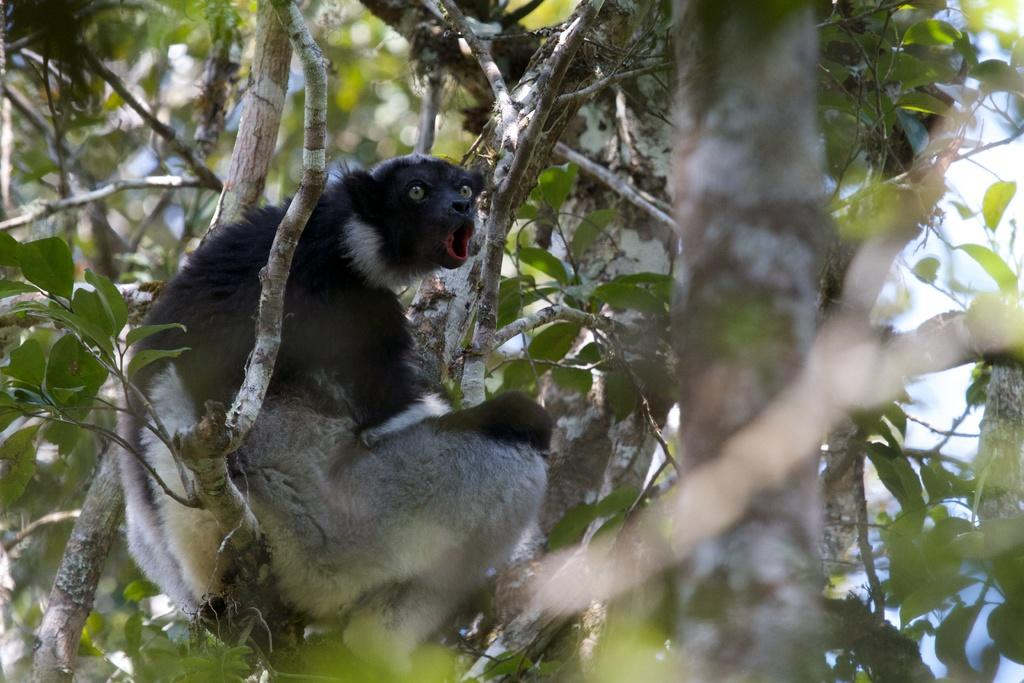What is on the tree branch in the image? There is an animal on a tree branch in the image. What can be seen in the background of the image? There are leaves visible in the background of the image. How would you describe the background of the image? The background is blurry. What type of hydrant is visible in the image? There is no hydrant present in the image. How does the animal use the stamp in the image? There is no stamp present in the image, so the animal cannot use it. 